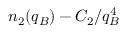<formula> <loc_0><loc_0><loc_500><loc_500>n _ { 2 } ( q _ { B } ) - C _ { 2 } / q _ { B } ^ { 4 }</formula> 